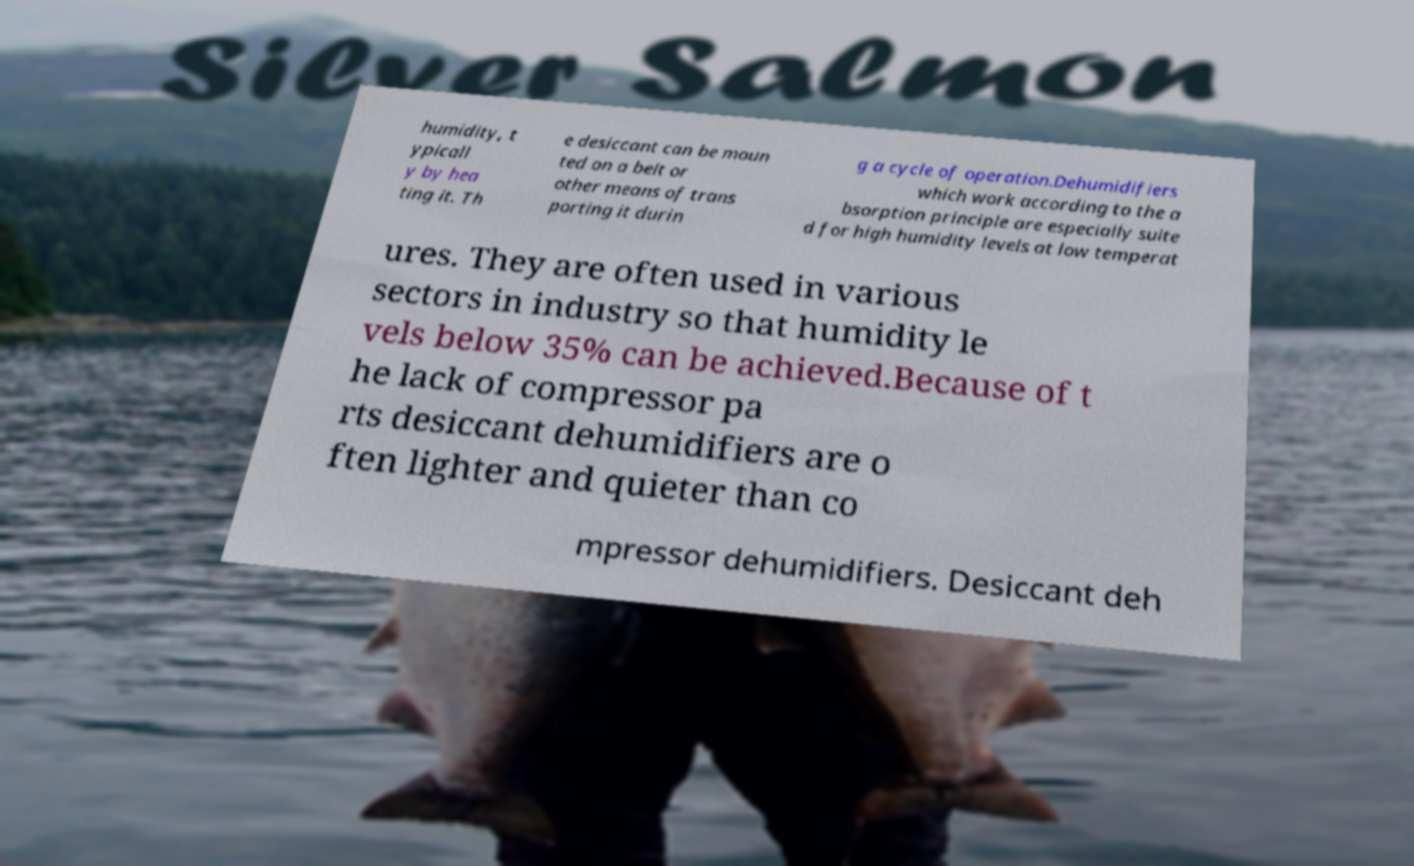Can you accurately transcribe the text from the provided image for me? humidity, t ypicall y by hea ting it. Th e desiccant can be moun ted on a belt or other means of trans porting it durin g a cycle of operation.Dehumidifiers which work according to the a bsorption principle are especially suite d for high humidity levels at low temperat ures. They are often used in various sectors in industry so that humidity le vels below 35% can be achieved.Because of t he lack of compressor pa rts desiccant dehumidifiers are o ften lighter and quieter than co mpressor dehumidifiers. Desiccant deh 